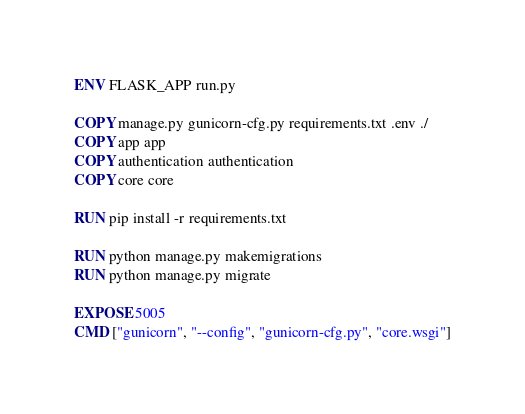Convert code to text. <code><loc_0><loc_0><loc_500><loc_500><_Dockerfile_>
ENV FLASK_APP run.py

COPY manage.py gunicorn-cfg.py requirements.txt .env ./
COPY app app
COPY authentication authentication
COPY core core

RUN pip install -r requirements.txt

RUN python manage.py makemigrations
RUN python manage.py migrate

EXPOSE 5005
CMD ["gunicorn", "--config", "gunicorn-cfg.py", "core.wsgi"]
</code> 